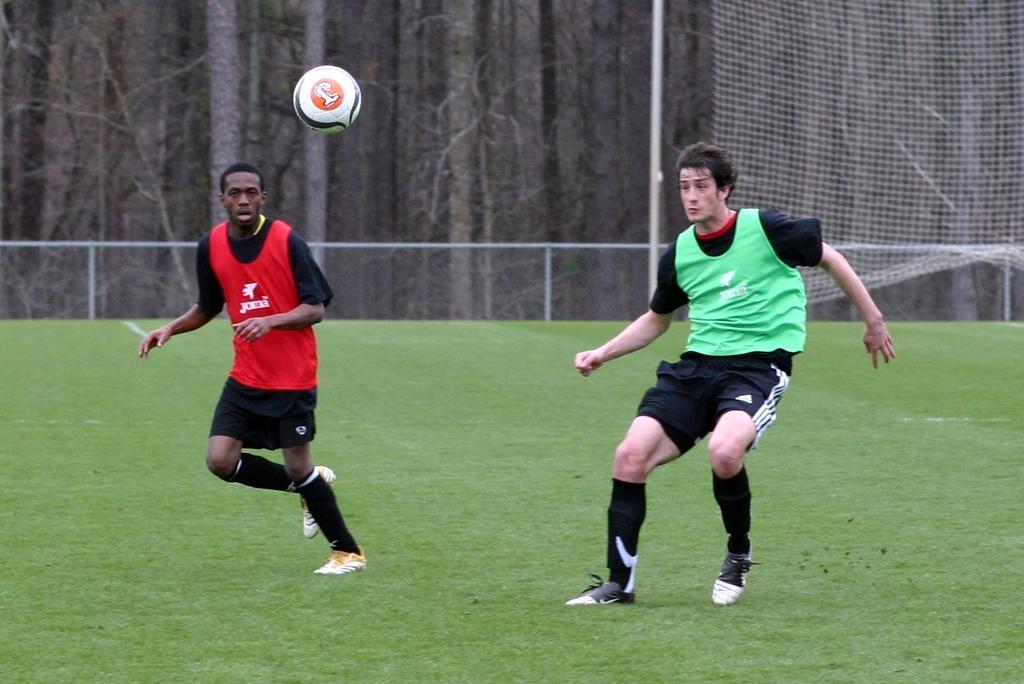Could you give a brief overview of what you see in this image? In this image I can see two persons. There is a ball, there is fencing, there is sports net and in the background there are trees. 